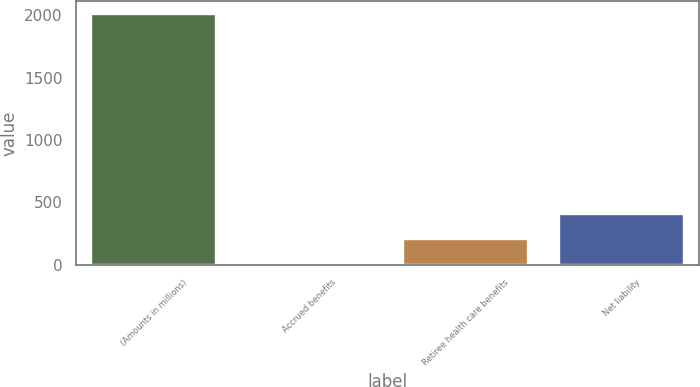Convert chart to OTSL. <chart><loc_0><loc_0><loc_500><loc_500><bar_chart><fcel>(Amounts in millions)<fcel>Accrued benefits<fcel>Retiree health care benefits<fcel>Net liability<nl><fcel>2013<fcel>4.8<fcel>205.62<fcel>406.44<nl></chart> 